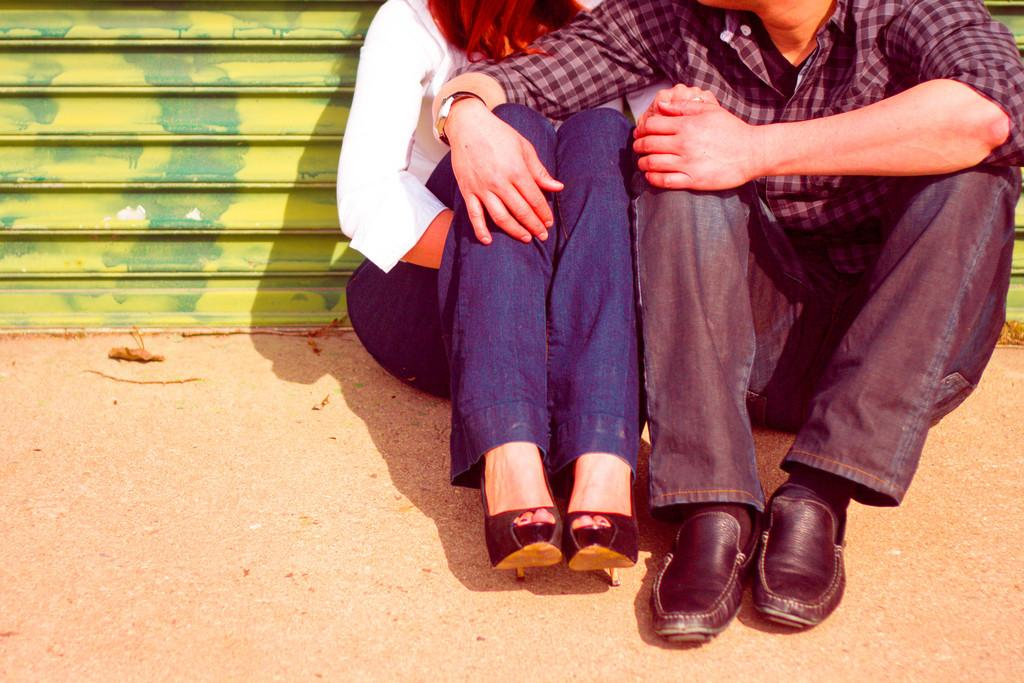Who are the people in the image? There is a lady and a guy in the image. What are they doing in the image? Both the lady and the guy are sitting on the floor. What is behind them in the image? They are sitting in front of a shutter. What type of toothpaste is the lady using in the image? There is no toothpaste present in the image; the lady and the guy are sitting on the floor in front of a shutter. 